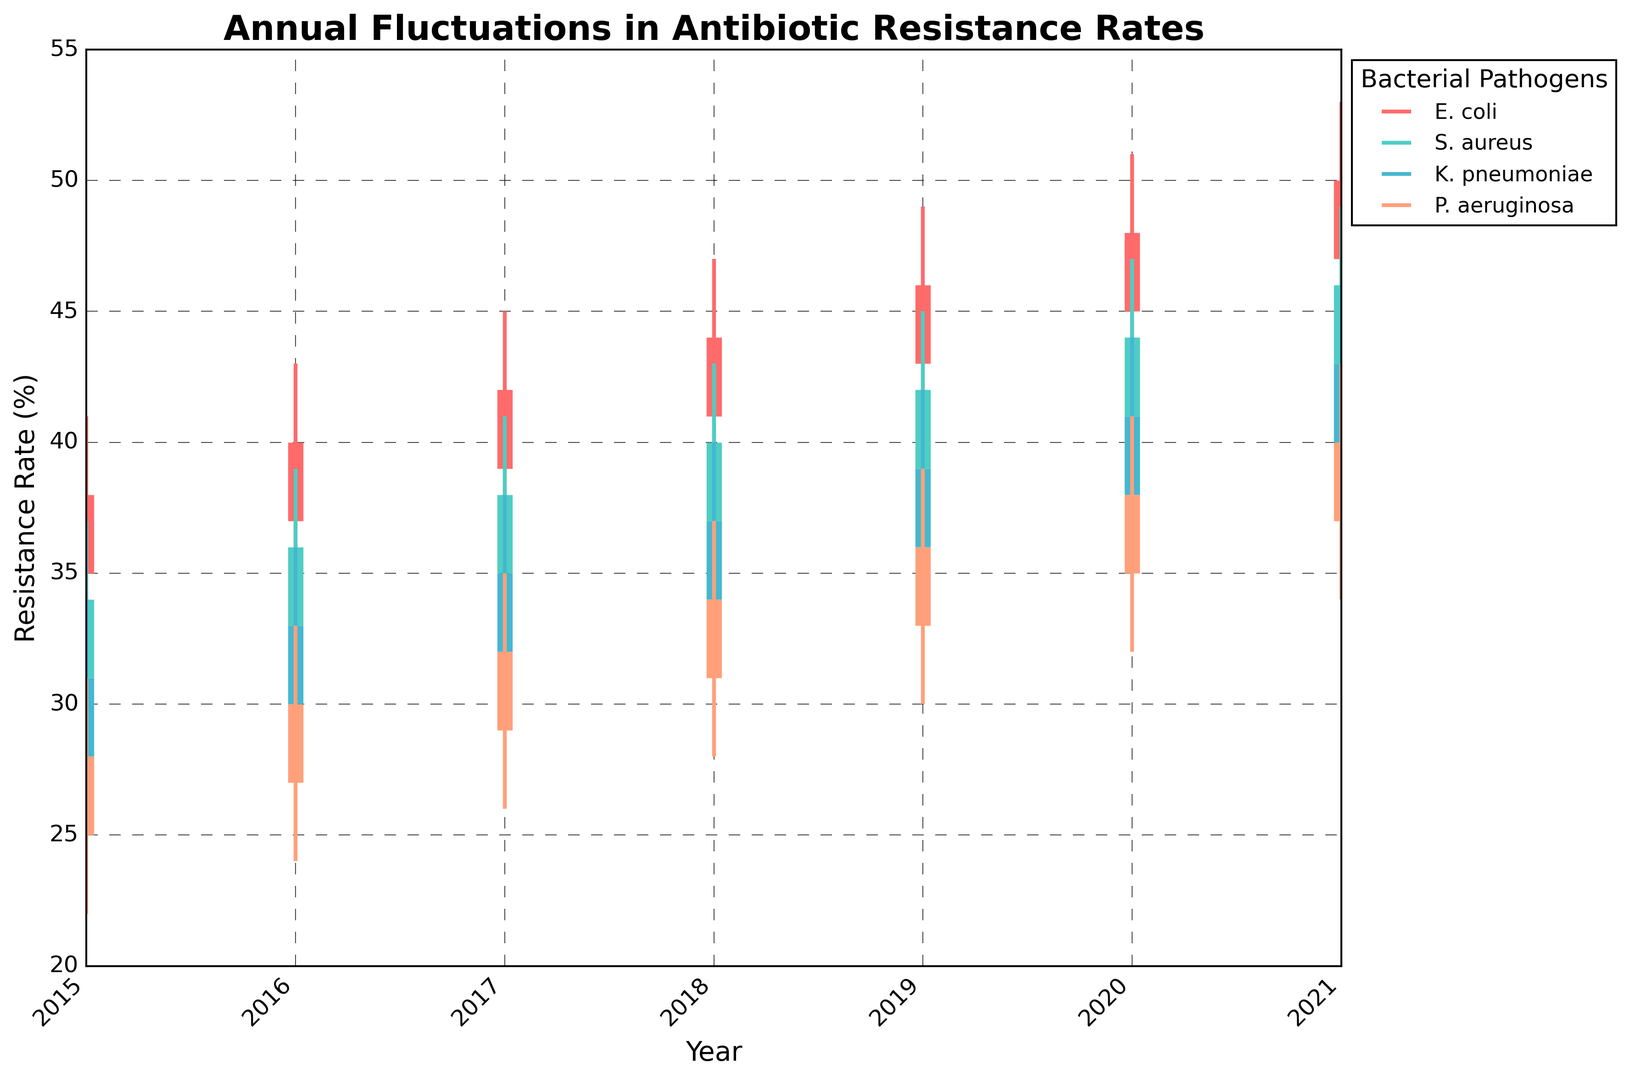How did the resistance rates of E. coli change from 2015 to 2021? To determine the change in resistance rates for E. coli from 2015 to 2021, examine the 'Close' values for these years. The 'Close' values represent the median resistance rates for E. coli each year: 2015 (38), 2021 (50). The resistance increased from 38% to 50%.
Answer: Increased from 38% to 50% Which pathogen had the highest median resistance rate in 2021? To find the pathogen with the highest median resistance rate in 2021, compare the 'Close' values for each pathogen in that year. The 'Close' values are: E. coli (50), S. aureus (46), K. pneumoniae (43), P. aeruginosa (40). E. coli had the highest median resistance rate.
Answer: E. coli How does the increase in median resistance rates of P. aeruginosa from 2015 to 2021 compare to that of K. pneumoniae over the same period? First, find the 'Close' values for P. aeruginosa for 2015 (28) and 2021 (40), then for K. pneumoniae in 2015 (31) and 2021 (43). Calculate the increase for each: P. aeruginosa (40-28=12), K. pneumoniae (43-31=12). Both pathogens had an equal increase of 12%.
Answer: Both increased by 12% What is the general trend of resistance rates for S. aureus from 2015 onwards as indicated by the chart? Examine the 'Close' values for S. aureus from 2015 to 2021. The values are: 2015 (34), 2016 (36), 2017 (38), 2018 (40), 2019 (42), 2020 (44), 2021 (46). The resistance rates show a consistent upward trend over the period.
Answer: Upward trend During which year did K. pneumoniae and P. aeruginosa have the same highest resistance rate? Identify years where the 'High' values for both K. pneumoniae and P. aeruginosa match. In 2019, 'High' for K. pneumoniae (42) and P. aeruginosa (39) do not match. The same applies to other years until we find no match within the provided data. Therefore, they never had the same highest resistance rate in the given period.
Answer: Never matched How does the range of resistance rates (from Low to High) for E. coli in 2020 compare to that in 2018? Calculate the range by subtracting 'Low' from 'High' for E. coli in the respective years: 2020 (51-42=9), 2018 (47-38=9). The ranges are the same for both years.
Answer: Same range of 9 Which pathogen had the most consistent median resistance rate increase year over year? Check the 'Close' values for each pathogen year by year. E. coli and S. aureus increased their resistance rates by 3% per year consistently: E. coli (2015-2021: 38, 40, 42, 44, 46, 48, 50), S. aureus (34, 36, 38, 40, 42, 44, 46). Other pathogens showed similar trends but with some variations.
Answer: E. coli and S. aureus Which pathogen had the smallest range of resistance rates in 2016? Compare the range (High - Low) for each pathogen in 2016: E. coli (43-34=9), S. aureus (39-30=9), K. pneumoniae (36-27=9), P. aeruginosa (33-24=9). Each pathogen had a range of 9, so they all had the same smallest range.
Answer: All equal at 9 Which pathogen showed a significant increase in the high resistance rate from 2015 to 2021? Compare the 'High' values for each pathogen from 2015 to 2021 and determine the increase: E. coli (51-41=10), S. aureus (49-37=12), K. pneumoniae (46-34=12), P. aeruginosa (43-31=12). S. aureus, K. pneumoniae, and P. aeruginosa showed significant increases.
Answer: S. aureus, K. pneumoniae, and P. aeruginosa What is the median resistance rate for K. pneumoniae in 2019? Look at the 'Close' value for K. pneumoniae in 2019, which is the median value. The value is 39.
Answer: 39 